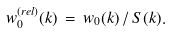Convert formula to latex. <formula><loc_0><loc_0><loc_500><loc_500>w _ { 0 } ^ { ( r e l ) } ( k ) \, = \, w _ { 0 } ( k ) \, / \, S ( k ) .</formula> 